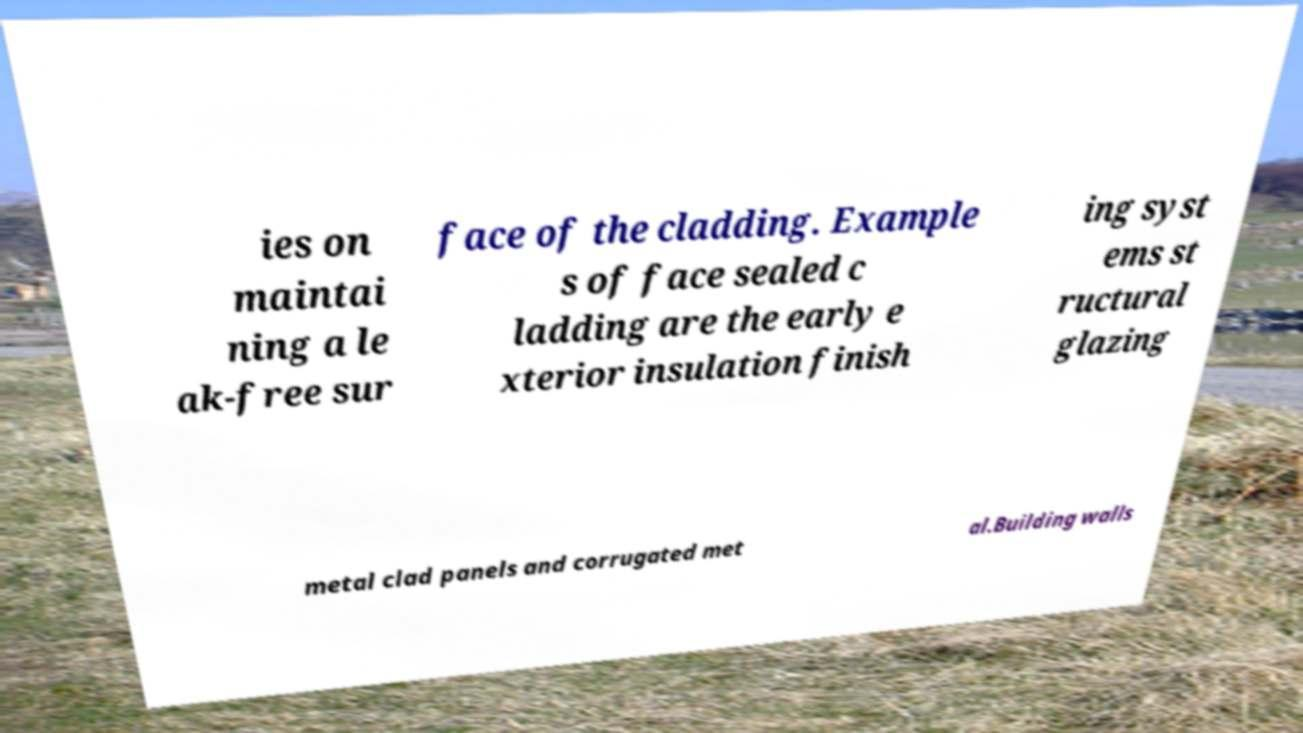What messages or text are displayed in this image? I need them in a readable, typed format. ies on maintai ning a le ak-free sur face of the cladding. Example s of face sealed c ladding are the early e xterior insulation finish ing syst ems st ructural glazing metal clad panels and corrugated met al.Building walls 